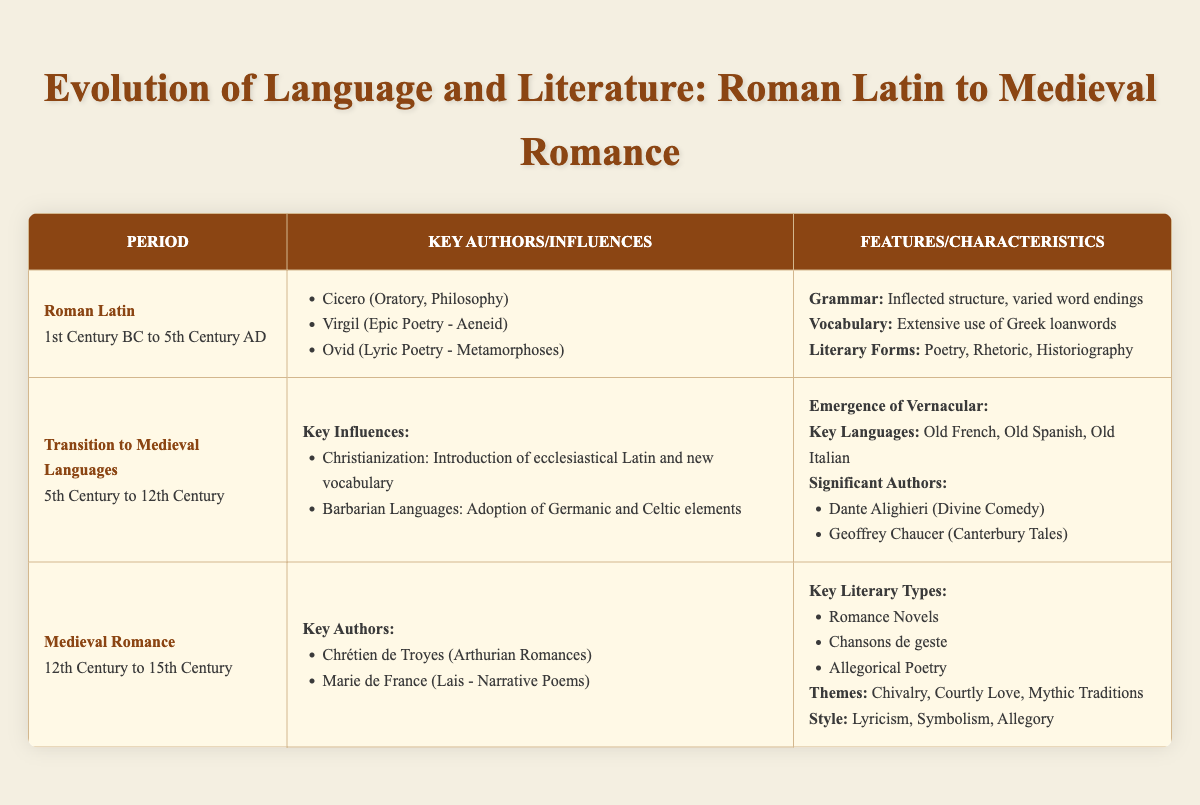What period does Roman Latin span? From the table, the period for Roman Latin is indicated as "1st Century BC to 5th Century AD." This is clearly stated under the Roman Latin section.
Answer: 1st Century BC to 5th Century AD Who are two significant authors from the Medieval Romance period? In the Medieval Romance section, the key authors listed are Chrétien de Troyes and Marie de France. The table provides their names under the "Key Authors" category.
Answer: Chrétien de Troyes, Marie de France What influence introduced ecclesiastical Latin during the transition to Medieval languages? The table lists "Christianization" as a key influence in the Transition to Medieval Languages section, highlighting its impact of introducing ecclesiastical Latin and new vocabulary.
Answer: Christianization Which key literary types are associated with Medieval Romance? The table specifies that the key literary types of Medieval Romance include Romance Novels, Chansons de geste, and Allegorical Poetry. This information is found under the "Key Literary Types" section.
Answer: Romance Novels, Chansons de geste, Allegorical Poetry Was Virgil known for his work in epic poetry? The entry for Virgil in the Roman Latin section states that he contributed to epic poetry with his work "Aeneid." Thus, the statement is true based on the information presented in the table.
Answer: Yes How many significant authors are listed under the "Emergence of Vernacular"? In the table, there are two significant authors listed under the "Emergence of Vernacular" section: Dante Alighieri and Geoffrey Chaucer. Therefore, the total count is simply two.
Answer: 2 What are the themes prevalent in Medieval Romance literature? The table notes that Medieval Romance literature commonly features themes of Chivalry, Courtly Love, and Mythic Traditions. This information can be found in the "Characteristics" section under Medieval Romance.
Answer: Chivalry, Courtly Love, Mythic Traditions How did barbarian languages influence the transition to Medieval languages? According to the table, the influence of "Barbarian Languages" led to the adoption of Germanic and Celtic elements, stated under the "Key Influences" section during the Transition to Medieval Languages. This indicates a blending of linguistic elements.
Answer: Germanic and Celtic elements What literary form was prevalent in Roman Latin alongside Poetry and Rhetoric? The table lists "Historiography" as one of the literary forms prevalent during the Roman Latin period, along with Poetry and Rhetoric, which can be found in the "Literary Forms" category.
Answer: Historiography 